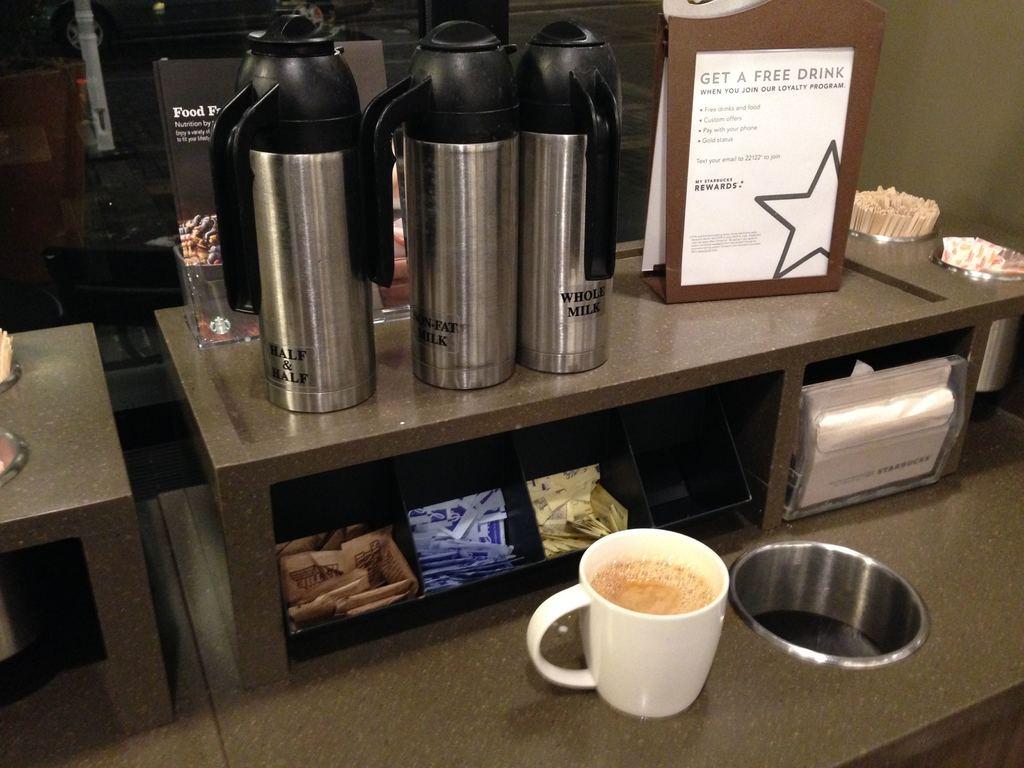What is the sign above the napkins for?
Your answer should be very brief. Get a free drink. Do they have a rewards program?
Provide a short and direct response. Yes. 